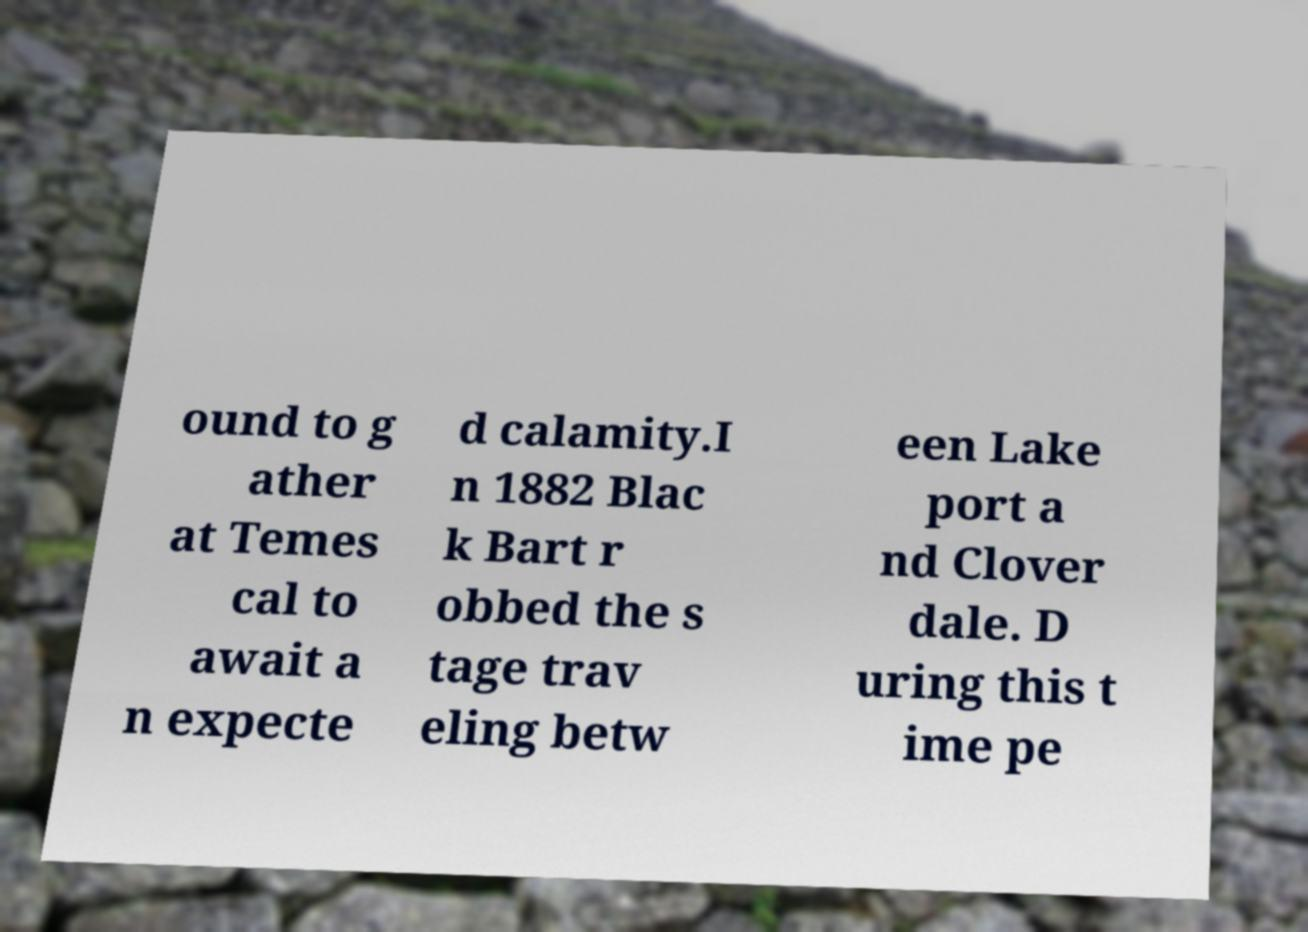Please identify and transcribe the text found in this image. ound to g ather at Temes cal to await a n expecte d calamity.I n 1882 Blac k Bart r obbed the s tage trav eling betw een Lake port a nd Clover dale. D uring this t ime pe 